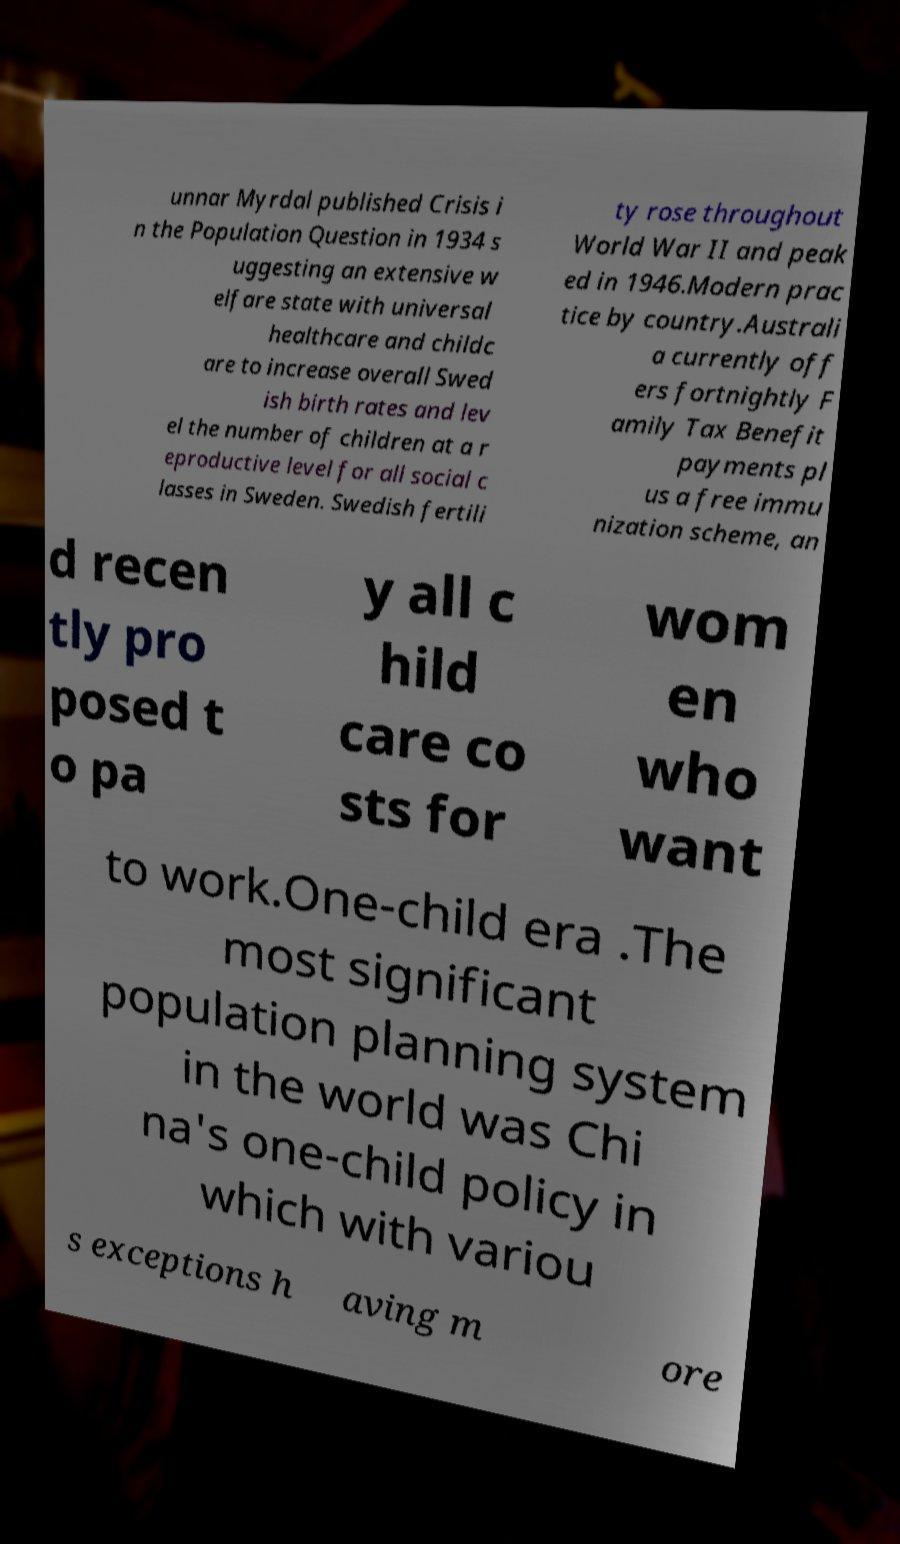What messages or text are displayed in this image? I need them in a readable, typed format. unnar Myrdal published Crisis i n the Population Question in 1934 s uggesting an extensive w elfare state with universal healthcare and childc are to increase overall Swed ish birth rates and lev el the number of children at a r eproductive level for all social c lasses in Sweden. Swedish fertili ty rose throughout World War II and peak ed in 1946.Modern prac tice by country.Australi a currently off ers fortnightly F amily Tax Benefit payments pl us a free immu nization scheme, an d recen tly pro posed t o pa y all c hild care co sts for wom en who want to work.One-child era .The most significant population planning system in the world was Chi na's one-child policy in which with variou s exceptions h aving m ore 